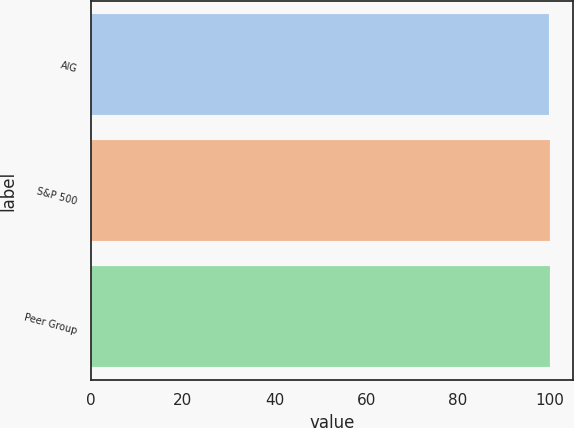Convert chart. <chart><loc_0><loc_0><loc_500><loc_500><bar_chart><fcel>AIG<fcel>S&P 500<fcel>Peer Group<nl><fcel>100<fcel>100.1<fcel>100.2<nl></chart> 